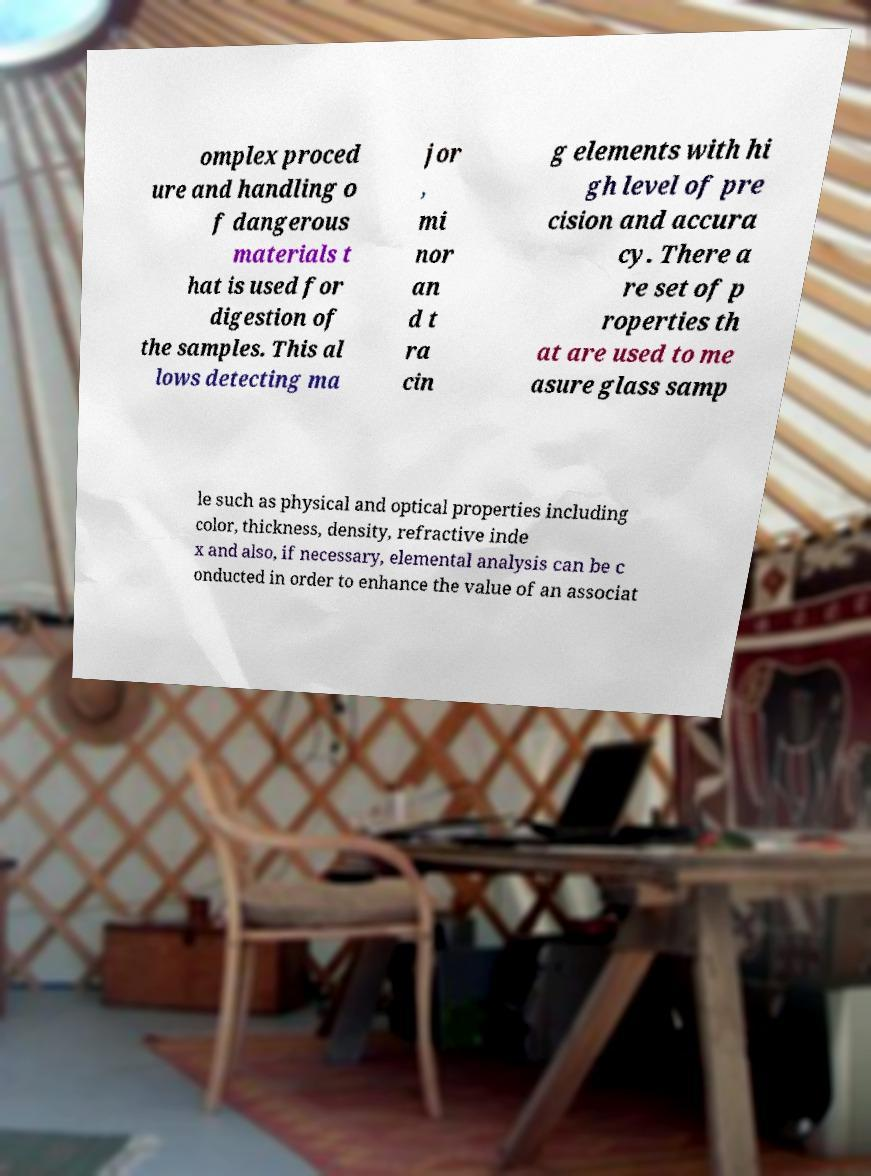Please read and relay the text visible in this image. What does it say? omplex proced ure and handling o f dangerous materials t hat is used for digestion of the samples. This al lows detecting ma jor , mi nor an d t ra cin g elements with hi gh level of pre cision and accura cy. There a re set of p roperties th at are used to me asure glass samp le such as physical and optical properties including color, thickness, density, refractive inde x and also, if necessary, elemental analysis can be c onducted in order to enhance the value of an associat 